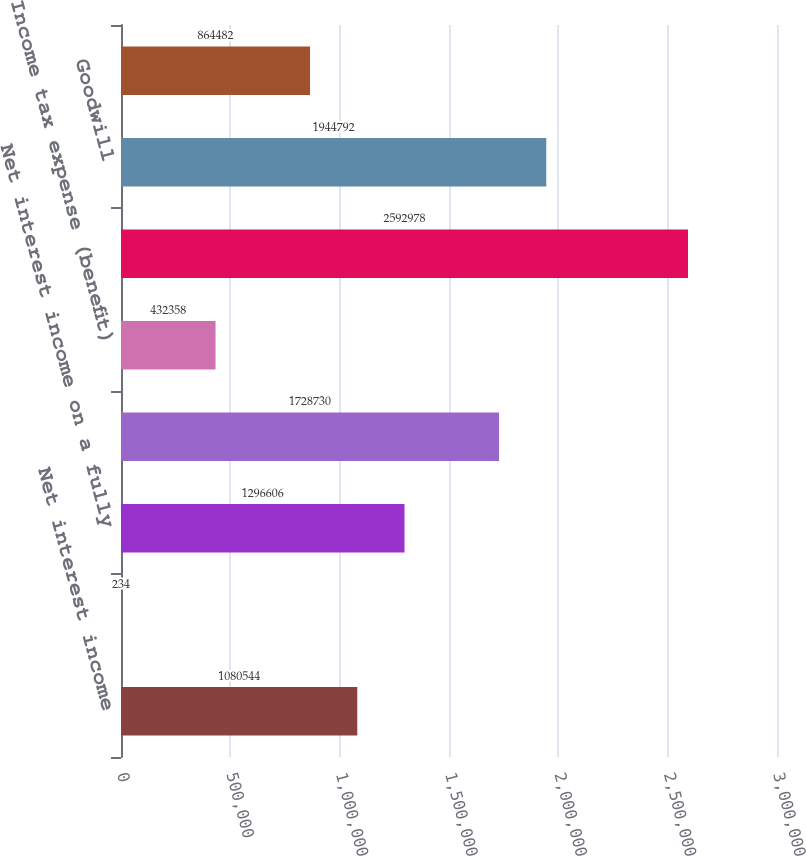<chart> <loc_0><loc_0><loc_500><loc_500><bar_chart><fcel>Net interest income<fcel>Fully taxable-equivalent<fcel>Net interest income on a fully<fcel>Total revenue net of interest<fcel>Income tax expense (benefit)<fcel>Common shareholders' equity<fcel>Goodwill<fcel>Intangible assets (excluding<nl><fcel>1.08054e+06<fcel>234<fcel>1.29661e+06<fcel>1.72873e+06<fcel>432358<fcel>2.59298e+06<fcel>1.94479e+06<fcel>864482<nl></chart> 